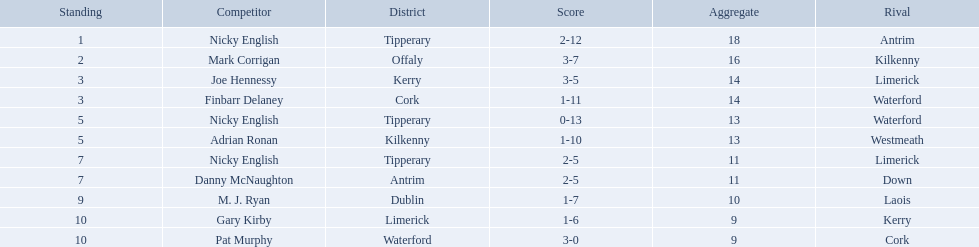Which of the following players were ranked in the bottom 5? Nicky English, Danny McNaughton, M. J. Ryan, Gary Kirby, Pat Murphy. Of these, whose tallies were not 2-5? M. J. Ryan, Gary Kirby, Pat Murphy. From the above three, which one scored more than 9 total points? M. J. Ryan. What numbers are in the total column? 18, 16, 14, 14, 13, 13, 11, 11, 10, 9, 9. What row has the number 10 in the total column? 9, M. J. Ryan, Dublin, 1-7, 10, Laois. What name is in the player column for this row? M. J. Ryan. Who are all the players? Nicky English, Mark Corrigan, Joe Hennessy, Finbarr Delaney, Nicky English, Adrian Ronan, Nicky English, Danny McNaughton, M. J. Ryan, Gary Kirby, Pat Murphy. How many points did they receive? 18, 16, 14, 14, 13, 13, 11, 11, 10, 9, 9. And which player received 10 points? M. J. Ryan. 